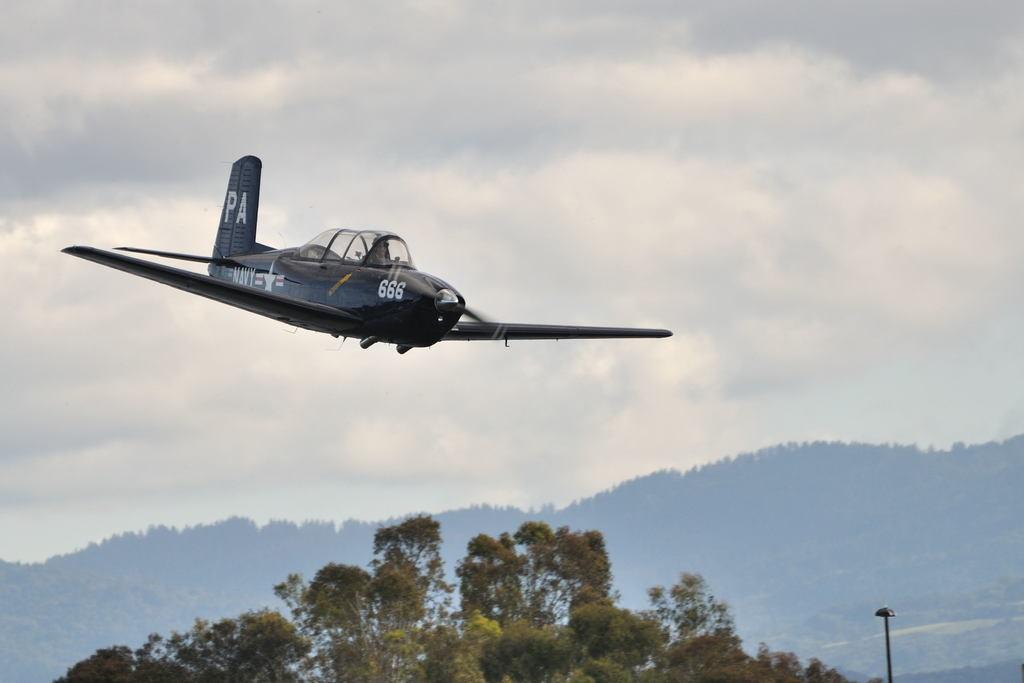What letters are on the tail of the plane?
Your answer should be very brief. Pa. Is any one is walking  in this road?
Your response must be concise. Answering does not require reading text in the image. 